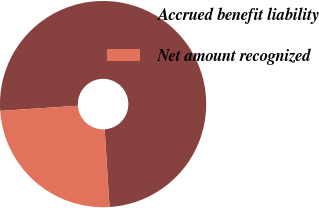<chart> <loc_0><loc_0><loc_500><loc_500><pie_chart><fcel>Accrued benefit liability<fcel>Net amount recognized<nl><fcel>75.06%<fcel>24.94%<nl></chart> 